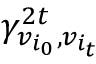Convert formula to latex. <formula><loc_0><loc_0><loc_500><loc_500>\gamma _ { v _ { i _ { 0 } } , v _ { i _ { t } } } ^ { 2 t }</formula> 